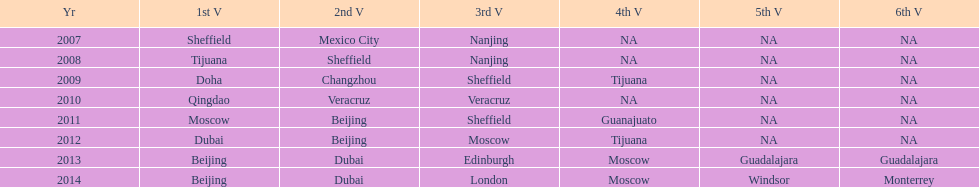Which is the only year that mexico is on a venue 2007. 